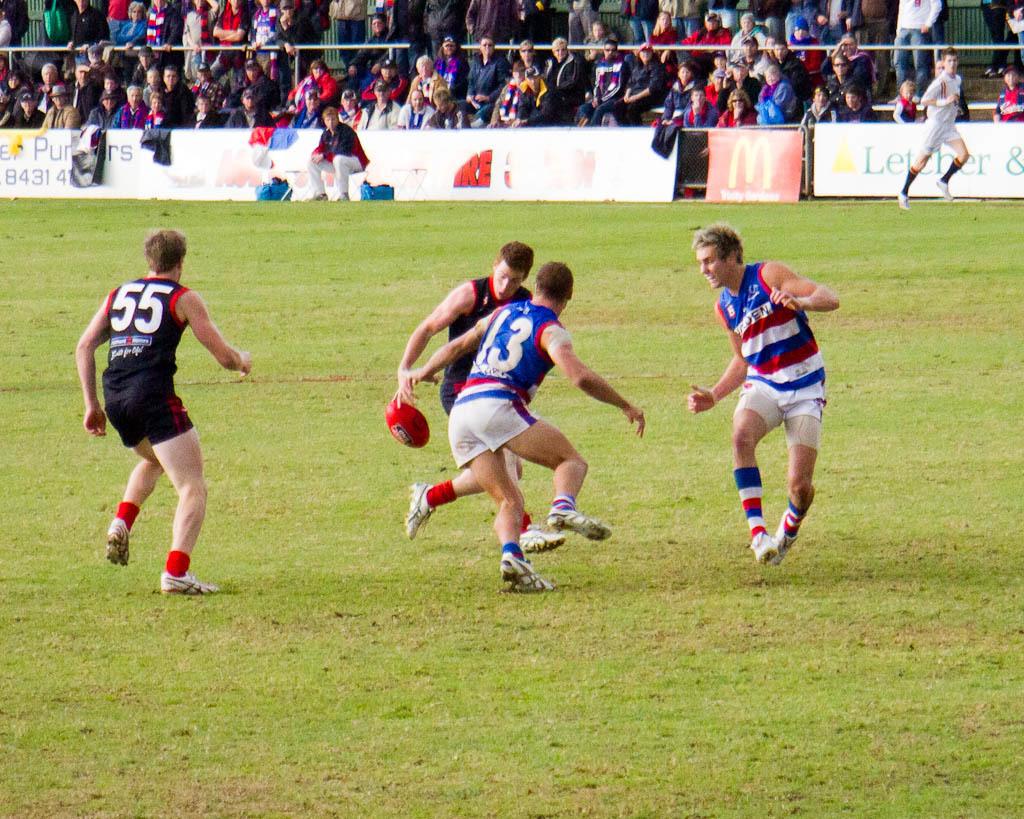What number is on the back of the black jersey?
Make the answer very short. 55. 